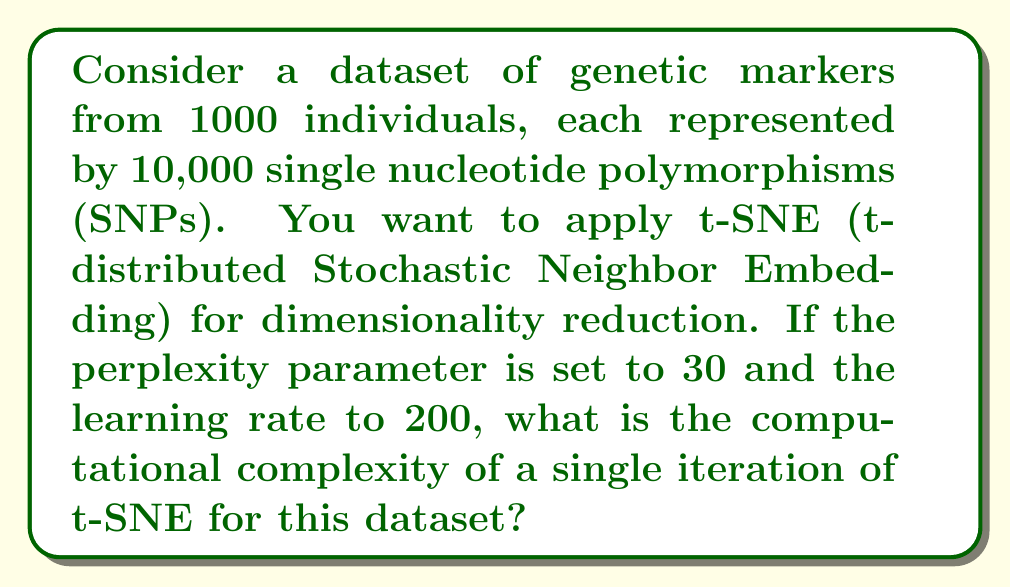Could you help me with this problem? To determine the computational complexity of a single t-SNE iteration, we need to consider the main steps of the algorithm:

1. Compute pairwise similarities in high-dimensional space:
   - Time complexity: $O(n^2d)$, where $n$ is the number of data points and $d$ is the original dimension.
   - In this case, $n = 1000$ and $d = 10000$

2. Compute pairwise similarities in low-dimensional space:
   - Time complexity: $O(n^2)$

3. Compute gradients:
   - Time complexity: $O(n^2)$

4. Update low-dimensional coordinates:
   - Time complexity: $O(n)$

The overall time complexity is dominated by the pairwise similarity computations:

$$O(n^2d + n^2) = O(n^2d)$$

Substituting the values:

$$O(1000^2 \cdot 10000) = O(10^{10})$$

The space complexity is $O(n^2)$ for storing pairwise similarities.

Note that the perplexity (30) and learning rate (200) don't affect the computational complexity directly, but they influence the number of iterations needed for convergence.

The Barnes-Hut approximation can reduce the complexity to $O(n \log n)$, but the question asks for the standard t-SNE implementation.
Answer: $O(10^{10})$ 